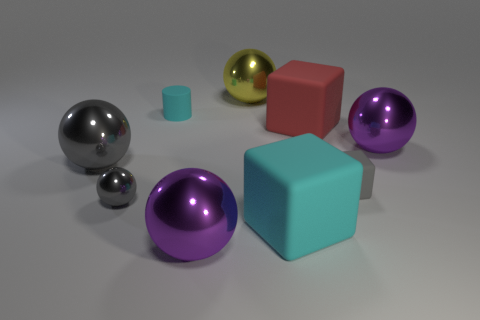How would you describe the arrangement and composition of the objects? The arrangement of the objects in the scene is balanced yet dynamic. The objects are placed at varying distances and angles, creating a sense of depth and perspective. The color contrasts and varying sizes of the objects contribute to a harmonious but interesting visual composition that draws the viewer's eye across the image. 